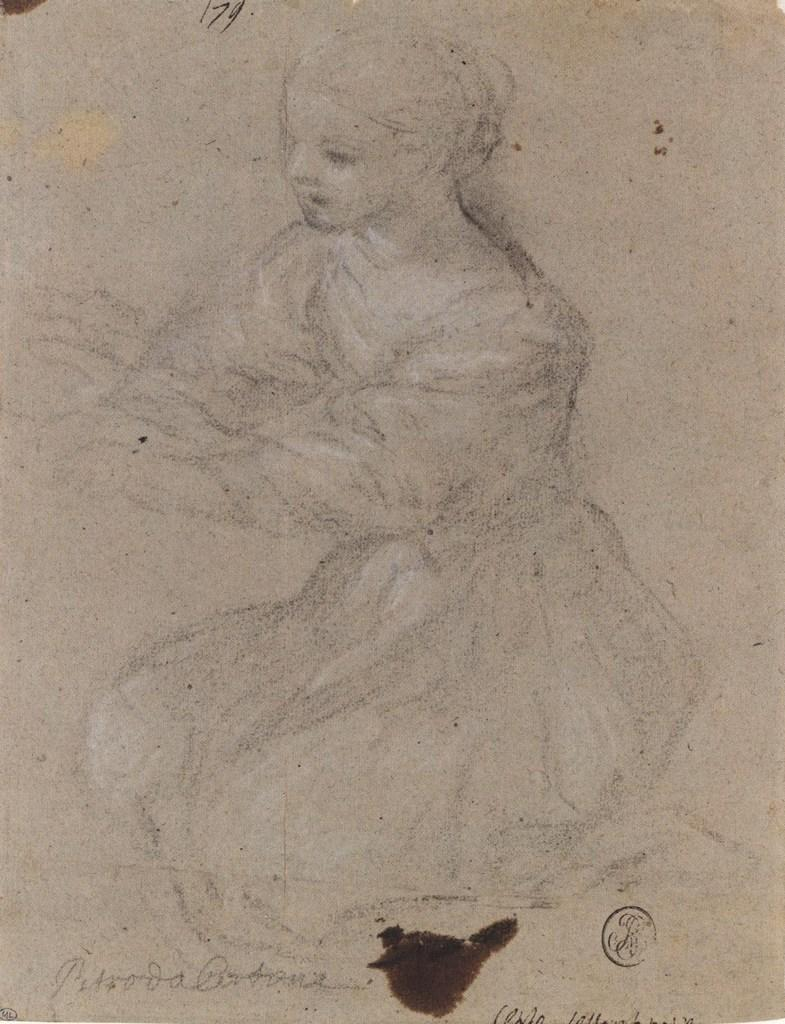What is the main subject in the center of the image? There is a paper in the center of the image. What can be found on the paper? The paper contains a drawing and text. What does the drawing depict? The drawing depicts a woman. How many girls are playing in the range depicted in the image? There are no girls or range present in the image; it features a paper with a drawing of a woman and text. 